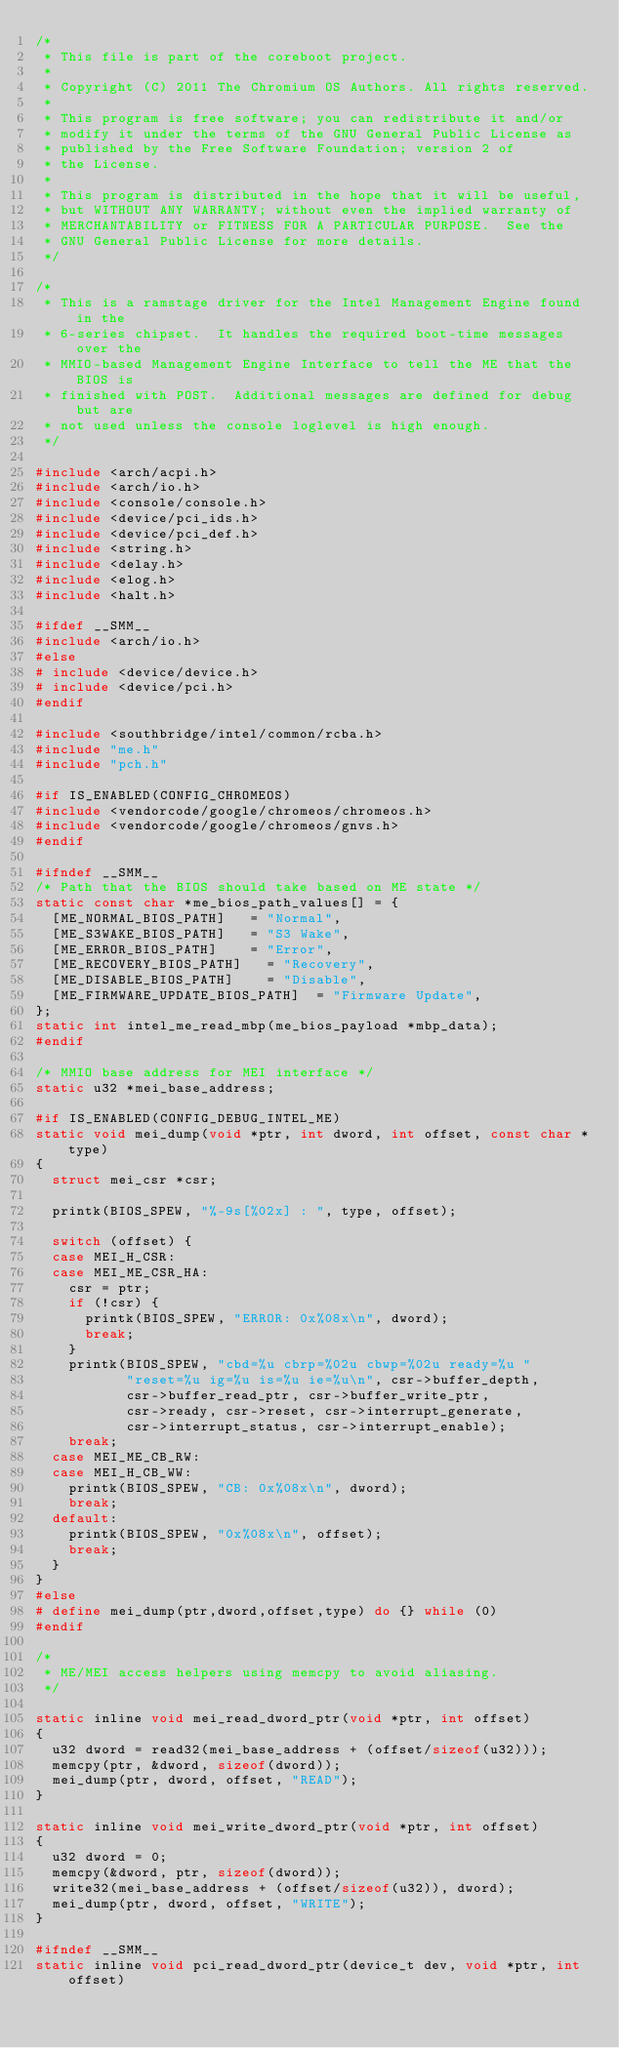Convert code to text. <code><loc_0><loc_0><loc_500><loc_500><_C_>/*
 * This file is part of the coreboot project.
 *
 * Copyright (C) 2011 The Chromium OS Authors. All rights reserved.
 *
 * This program is free software; you can redistribute it and/or
 * modify it under the terms of the GNU General Public License as
 * published by the Free Software Foundation; version 2 of
 * the License.
 *
 * This program is distributed in the hope that it will be useful,
 * but WITHOUT ANY WARRANTY; without even the implied warranty of
 * MERCHANTABILITY or FITNESS FOR A PARTICULAR PURPOSE.  See the
 * GNU General Public License for more details.
 */

/*
 * This is a ramstage driver for the Intel Management Engine found in the
 * 6-series chipset.  It handles the required boot-time messages over the
 * MMIO-based Management Engine Interface to tell the ME that the BIOS is
 * finished with POST.  Additional messages are defined for debug but are
 * not used unless the console loglevel is high enough.
 */

#include <arch/acpi.h>
#include <arch/io.h>
#include <console/console.h>
#include <device/pci_ids.h>
#include <device/pci_def.h>
#include <string.h>
#include <delay.h>
#include <elog.h>
#include <halt.h>

#ifdef __SMM__
#include <arch/io.h>
#else
# include <device/device.h>
# include <device/pci.h>
#endif

#include <southbridge/intel/common/rcba.h>
#include "me.h"
#include "pch.h"

#if IS_ENABLED(CONFIG_CHROMEOS)
#include <vendorcode/google/chromeos/chromeos.h>
#include <vendorcode/google/chromeos/gnvs.h>
#endif

#ifndef __SMM__
/* Path that the BIOS should take based on ME state */
static const char *me_bios_path_values[] = {
	[ME_NORMAL_BIOS_PATH]		= "Normal",
	[ME_S3WAKE_BIOS_PATH]		= "S3 Wake",
	[ME_ERROR_BIOS_PATH]		= "Error",
	[ME_RECOVERY_BIOS_PATH]		= "Recovery",
	[ME_DISABLE_BIOS_PATH]		= "Disable",
	[ME_FIRMWARE_UPDATE_BIOS_PATH]	= "Firmware Update",
};
static int intel_me_read_mbp(me_bios_payload *mbp_data);
#endif

/* MMIO base address for MEI interface */
static u32 *mei_base_address;

#if IS_ENABLED(CONFIG_DEBUG_INTEL_ME)
static void mei_dump(void *ptr, int dword, int offset, const char *type)
{
	struct mei_csr *csr;

	printk(BIOS_SPEW, "%-9s[%02x] : ", type, offset);

	switch (offset) {
	case MEI_H_CSR:
	case MEI_ME_CSR_HA:
		csr = ptr;
		if (!csr) {
			printk(BIOS_SPEW, "ERROR: 0x%08x\n", dword);
			break;
		}
		printk(BIOS_SPEW, "cbd=%u cbrp=%02u cbwp=%02u ready=%u "
		       "reset=%u ig=%u is=%u ie=%u\n", csr->buffer_depth,
		       csr->buffer_read_ptr, csr->buffer_write_ptr,
		       csr->ready, csr->reset, csr->interrupt_generate,
		       csr->interrupt_status, csr->interrupt_enable);
		break;
	case MEI_ME_CB_RW:
	case MEI_H_CB_WW:
		printk(BIOS_SPEW, "CB: 0x%08x\n", dword);
		break;
	default:
		printk(BIOS_SPEW, "0x%08x\n", offset);
		break;
	}
}
#else
# define mei_dump(ptr,dword,offset,type) do {} while (0)
#endif

/*
 * ME/MEI access helpers using memcpy to avoid aliasing.
 */

static inline void mei_read_dword_ptr(void *ptr, int offset)
{
	u32 dword = read32(mei_base_address + (offset/sizeof(u32)));
	memcpy(ptr, &dword, sizeof(dword));
	mei_dump(ptr, dword, offset, "READ");
}

static inline void mei_write_dword_ptr(void *ptr, int offset)
{
	u32 dword = 0;
	memcpy(&dword, ptr, sizeof(dword));
	write32(mei_base_address + (offset/sizeof(u32)), dword);
	mei_dump(ptr, dword, offset, "WRITE");
}

#ifndef __SMM__
static inline void pci_read_dword_ptr(device_t dev, void *ptr, int offset)</code> 